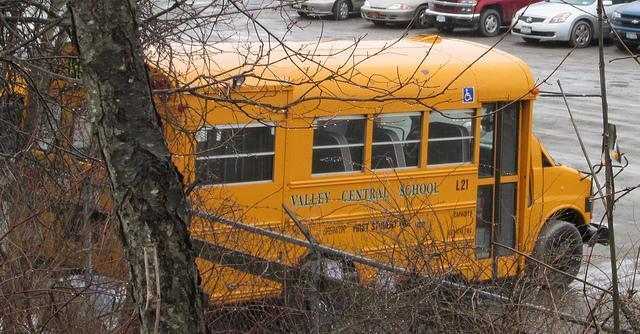How many buses can be seen?
Give a very brief answer. 1. 